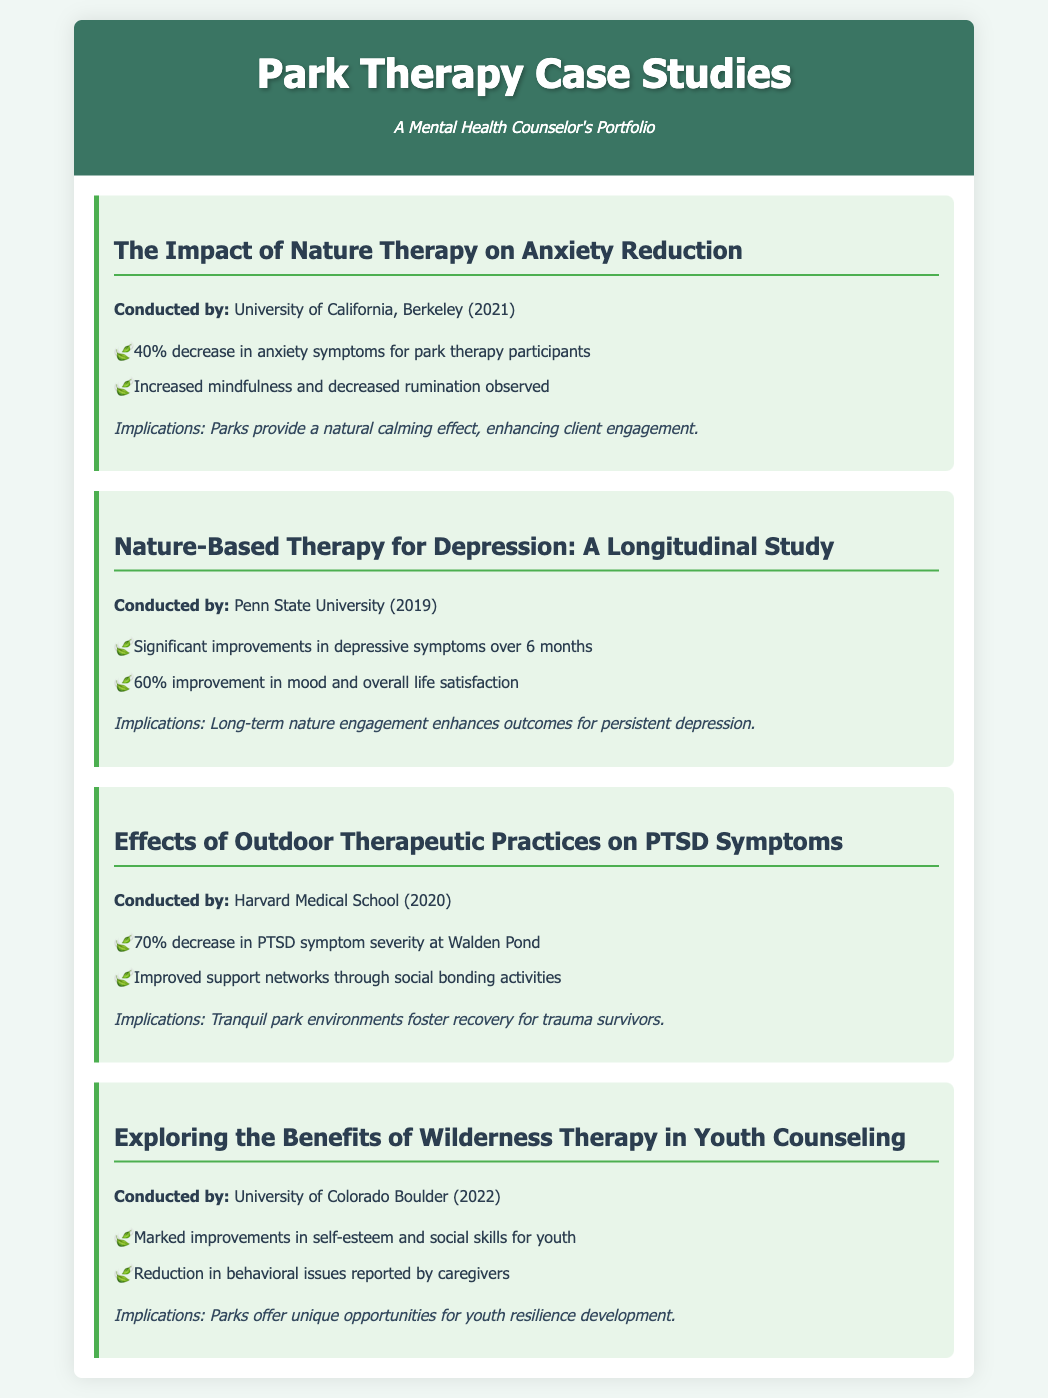what is the title of the first case study? The title of the first case study is given under "The Impact of Nature Therapy on Anxiety Reduction".
Answer: The Impact of Nature Therapy on Anxiety Reduction who conducted the second case study? The second case study was conducted by Penn State University.
Answer: Penn State University what percentage of anxiety symptom decrease was observed in the first case study? The first case study indicates a 40% decrease in anxiety symptoms for park therapy participants.
Answer: 40% how many months did the longitudinal study in the second case study last? The longitudinal study in the second case study lasted over 6 months.
Answer: 6 months what was the improvement percentage in mood reported in the second case study? The second case study reported a 60% improvement in mood and overall life satisfaction.
Answer: 60% what significant decrease in PTSD symptoms was noted in the third case study? The third case study noted a 70% decrease in PTSD symptom severity.
Answer: 70% which park was mentioned in the third case study for therapeutic practices? The park mentioned for therapeutic practices in the third case study is Walden Pond.
Answer: Walden Pond what year was the study on youth counseling conducted? The study on youth counseling was conducted in 2022.
Answer: 2022 what type of skills saw marked improvements according to the fourth case study? The fourth case study mentioned marked improvements in social skills for youth.
Answer: social skills 